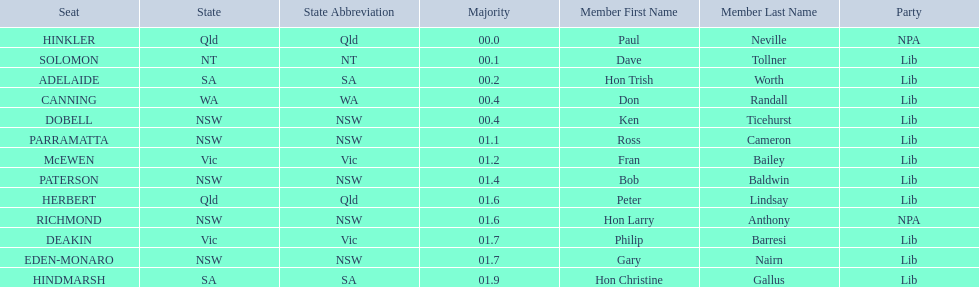Who are all the lib party members? Dave Tollner, Hon Trish Worth, Don Randall, Ken Ticehurst, Ross Cameron, Fran Bailey, Bob Baldwin, Peter Lindsay, Philip Barresi, Gary Nairn, Hon Christine Gallus. What lib party members are in sa? Hon Trish Worth, Hon Christine Gallus. What is the highest difference in majority between members in sa? 01.9. 